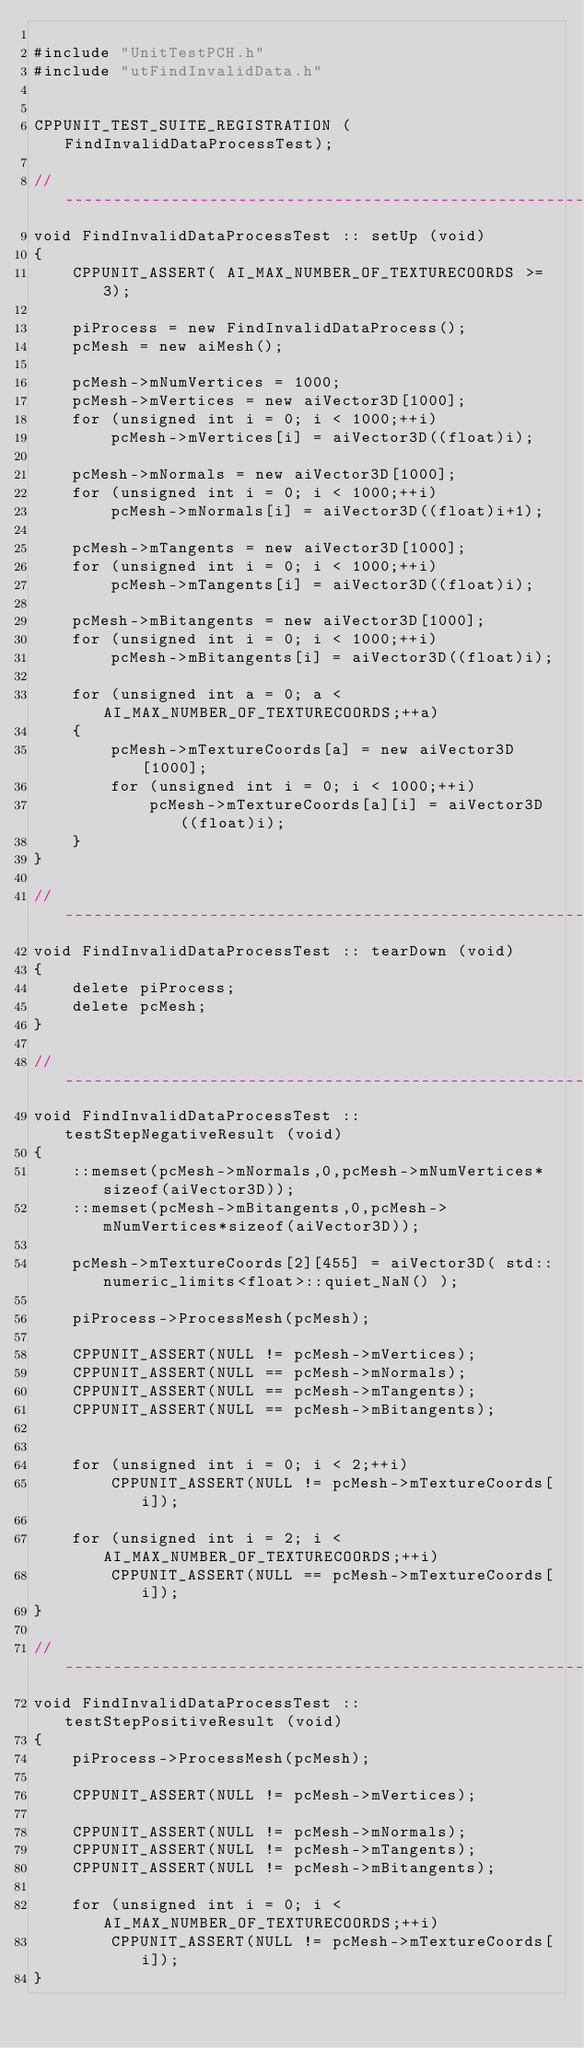<code> <loc_0><loc_0><loc_500><loc_500><_C++_>
#include "UnitTestPCH.h"
#include "utFindInvalidData.h"


CPPUNIT_TEST_SUITE_REGISTRATION (FindInvalidDataProcessTest);

// ------------------------------------------------------------------------------------------------
void FindInvalidDataProcessTest :: setUp (void)
{
	CPPUNIT_ASSERT( AI_MAX_NUMBER_OF_TEXTURECOORDS >= 3);

	piProcess = new FindInvalidDataProcess();
	pcMesh = new aiMesh();

	pcMesh->mNumVertices = 1000;
	pcMesh->mVertices = new aiVector3D[1000];
	for (unsigned int i = 0; i < 1000;++i)
		pcMesh->mVertices[i] = aiVector3D((float)i);

	pcMesh->mNormals = new aiVector3D[1000];
	for (unsigned int i = 0; i < 1000;++i)
		pcMesh->mNormals[i] = aiVector3D((float)i+1);

	pcMesh->mTangents = new aiVector3D[1000];
	for (unsigned int i = 0; i < 1000;++i)
		pcMesh->mTangents[i] = aiVector3D((float)i);

	pcMesh->mBitangents = new aiVector3D[1000];
	for (unsigned int i = 0; i < 1000;++i)
		pcMesh->mBitangents[i] = aiVector3D((float)i);

	for (unsigned int a = 0; a < AI_MAX_NUMBER_OF_TEXTURECOORDS;++a)
	{
		pcMesh->mTextureCoords[a] = new aiVector3D[1000];
		for (unsigned int i = 0; i < 1000;++i)
			pcMesh->mTextureCoords[a][i] = aiVector3D((float)i);
	}
}

// ------------------------------------------------------------------------------------------------
void FindInvalidDataProcessTest :: tearDown (void)
{
	delete piProcess;
	delete pcMesh;
}

// ------------------------------------------------------------------------------------------------
void FindInvalidDataProcessTest :: testStepNegativeResult (void)
{
	::memset(pcMesh->mNormals,0,pcMesh->mNumVertices*sizeof(aiVector3D));
	::memset(pcMesh->mBitangents,0,pcMesh->mNumVertices*sizeof(aiVector3D));

	pcMesh->mTextureCoords[2][455] = aiVector3D( std::numeric_limits<float>::quiet_NaN() );
	
	piProcess->ProcessMesh(pcMesh);

	CPPUNIT_ASSERT(NULL != pcMesh->mVertices);
	CPPUNIT_ASSERT(NULL == pcMesh->mNormals);
	CPPUNIT_ASSERT(NULL == pcMesh->mTangents);
	CPPUNIT_ASSERT(NULL == pcMesh->mBitangents);

	
	for (unsigned int i = 0; i < 2;++i)
		CPPUNIT_ASSERT(NULL != pcMesh->mTextureCoords[i]);
	
	for (unsigned int i = 2; i < AI_MAX_NUMBER_OF_TEXTURECOORDS;++i)
		CPPUNIT_ASSERT(NULL == pcMesh->mTextureCoords[i]);
}

// ------------------------------------------------------------------------------------------------
void FindInvalidDataProcessTest :: testStepPositiveResult (void)
{
	piProcess->ProcessMesh(pcMesh);

	CPPUNIT_ASSERT(NULL != pcMesh->mVertices);

	CPPUNIT_ASSERT(NULL != pcMesh->mNormals);
	CPPUNIT_ASSERT(NULL != pcMesh->mTangents);
	CPPUNIT_ASSERT(NULL != pcMesh->mBitangents);

	for (unsigned int i = 0; i < AI_MAX_NUMBER_OF_TEXTURECOORDS;++i)
		CPPUNIT_ASSERT(NULL != pcMesh->mTextureCoords[i]);
}</code> 